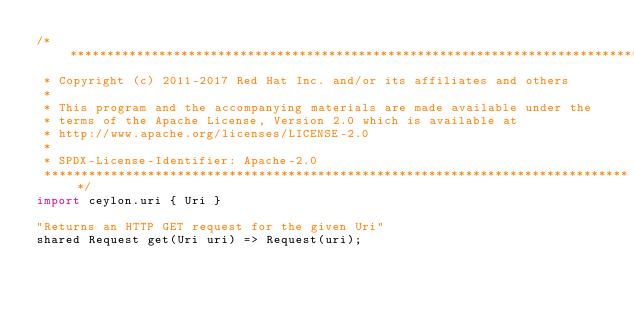Convert code to text. <code><loc_0><loc_0><loc_500><loc_500><_Ceylon_>/********************************************************************************
 * Copyright (c) 2011-2017 Red Hat Inc. and/or its affiliates and others
 *
 * This program and the accompanying materials are made available under the 
 * terms of the Apache License, Version 2.0 which is available at
 * http://www.apache.org/licenses/LICENSE-2.0
 *
 * SPDX-License-Identifier: Apache-2.0 
 ********************************************************************************/
import ceylon.uri { Uri }

"Returns an HTTP GET request for the given Uri"
shared Request get(Uri uri) => Request(uri);
</code> 